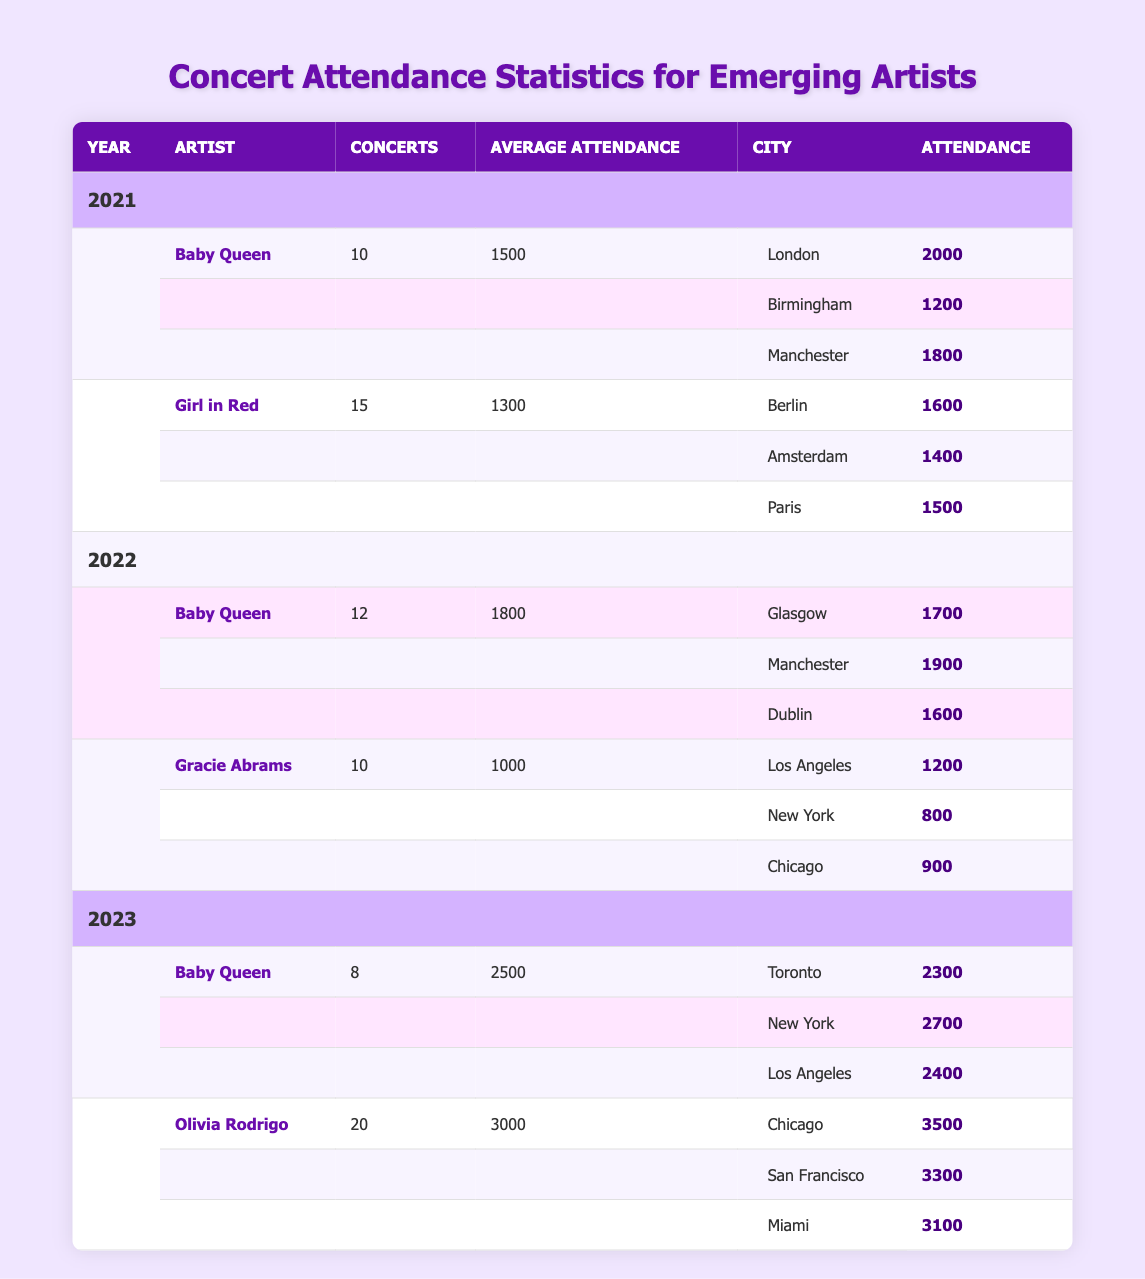What year did Baby Queen have the highest average attendance? Baby Queen had an average attendance of 2500 in 2023, while in 2021 it was 1500 and in 2022 it was 1800. Therefore, comparing these values, 2023 has the highest average attendance.
Answer: 2023 How many concerts did Girl in Red perform in total? In 2021, Girl in Red performed 15 concerts. The table does not provide data for 2022 or 2023 for Girl in Red, indicating that 15 is the total number of concerts recorded.
Answer: 15 What was the total attendance for Baby Queen in 2022? In 2022, Baby Queen had concerts in three cities: Glasgow (1700), Manchester (1900), and Dublin (1600). Summing these values gives 1700 + 1900 + 1600 = 5200. Therefore, the total attendance is 5200.
Answer: 5200 Did Baby Queen's average attendance increase from 2021 to 2023? In 2021, Baby Queen's average attendance was 1500, while in 2023 it was 2500. Since 2500 is greater than 1500, the average attendance indeed increased.
Answer: Yes Which artist had the highest average attendance in 2023? In 2023, Baby Queen had an average attendance of 2500, while Olivia Rodrigo had an average attendance of 3000. Because 3000 is higher than 2500, Olivia Rodrigo had the highest average attendance.
Answer: Olivia Rodrigo How many cities did Baby Queen perform in during 2021? In 2021, Baby Queen performed in three cities: London, Birmingham, and Manchester. Counting these gives a total of three cities.
Answer: 3 What is the difference in average attendance between Baby Queen in 2022 and Gracie Abrams in 2022? Baby Queen had an average attendance of 1800 in 2022, while Gracie Abrams had an average attendance of 1000. The difference between these two values is 1800 - 1000 = 800.
Answer: 800 Where did Olivia Rodrigo have the highest attendance? Olivia Rodrigo had the highest attendance in Chicago with 3500. In comparison, San Francisco had 3300 and Miami had 3100. Since 3500 is greater than both, Chicago is the location with the highest attendance.
Answer: Chicago How many concerts did Baby Queen perform in 2023? Baby Queen performed 8 concerts in 2023, as directly stated in the table.
Answer: 8 